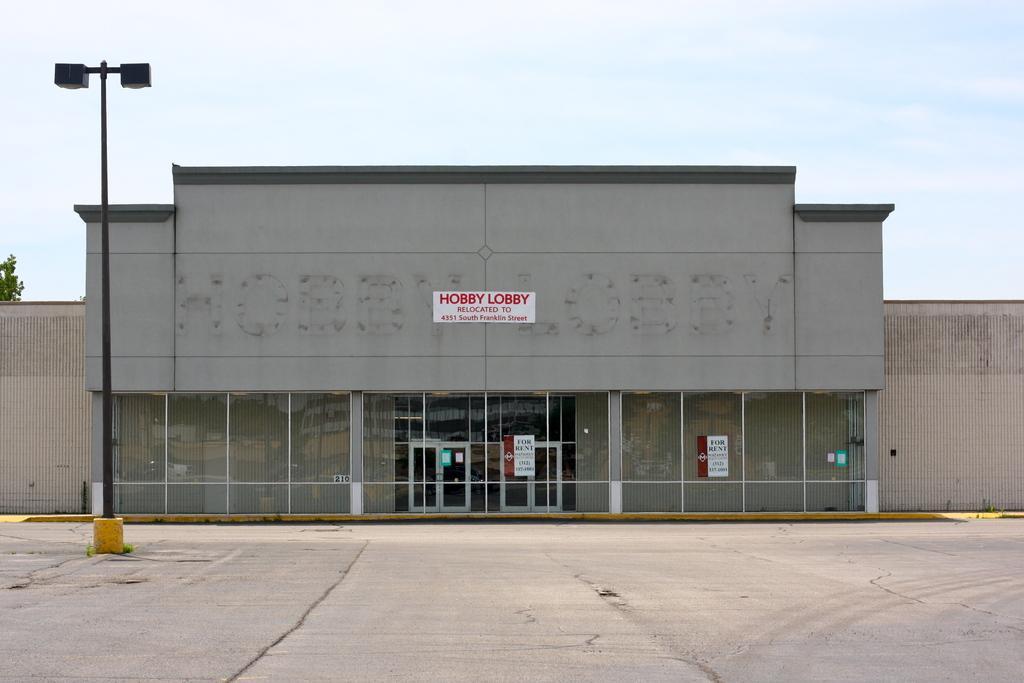Could you give a brief overview of what you see in this image? In this image, we can see a building and a pole. At the bottom, there is road. 